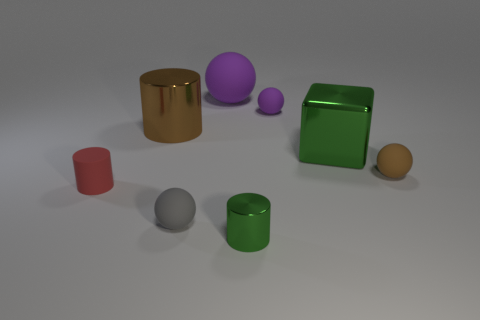Can you tell which object is the largest and what its color might signify? The largest object in the image appears to be the green cube. In color psychology, green can be associated with growth, renewal, and stability. Its size and color might make it a visual anchor in this group of objects. 